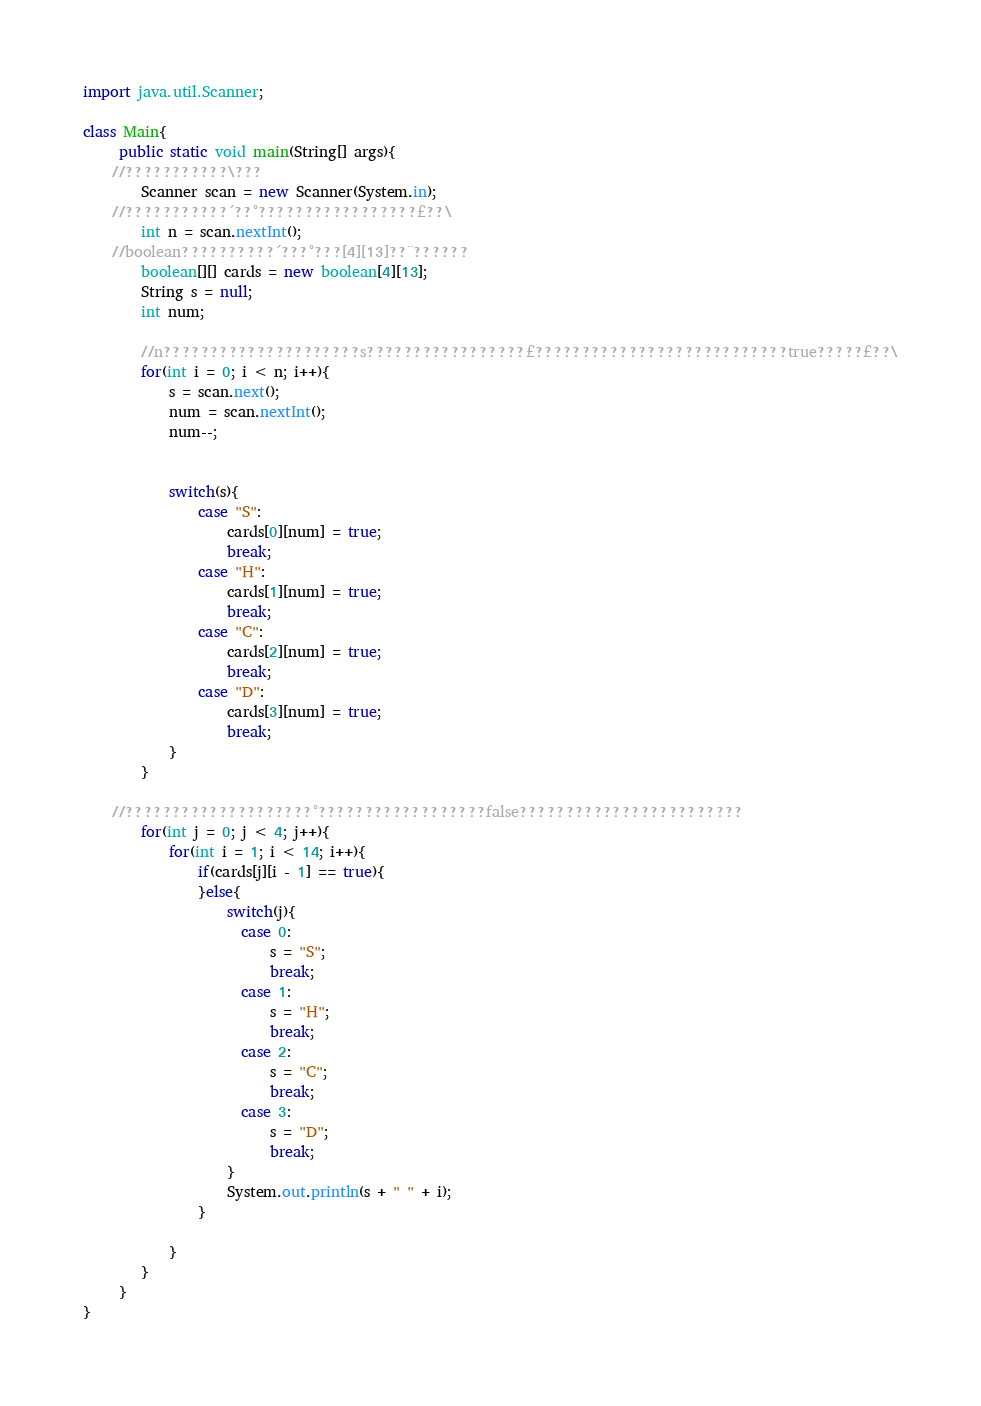Convert code to text. <code><loc_0><loc_0><loc_500><loc_500><_Java_>import java.util.Scanner;

class Main{
     public static void main(String[] args){
	//???????????\???
    	Scanner scan = new Scanner(System.in);
	//???????????´??°?????????????????£??\
    	int n = scan.nextInt();
	//boolean??????????´???°???[4][13]??¨??????
    	boolean[][] cards = new boolean[4][13];
    	String s = null;
    	int num;
    	
    	//n?????????????????????s?????????????????£???????????????????????????true?????£??\
    	for(int i = 0; i < n; i++){
    		s = scan.next();
    		num = scan.nextInt();
    		num--;
    		
    		
    		switch(s){
    			case "S":
    				cards[0][num] = true;
    				break;
    			case "H":
    				cards[1][num] = true;
    				break;
    			case "C":
    				cards[2][num] = true;
    				break;
    			case "D":
    				cards[3][num] = true;
    				break;
    		}
    	}
    	
	//????????????????????°??????????????????false????????????????????????
    	for(int j = 0; j < 4; j++){
    		for(int i = 1; i < 14; i++){
    			if(cards[j][i - 1] == true){   				
    			}else{
    				switch(j){
    				  case 0:
    					  s = "S";
    					  break;
    				  case 1:
    					  s = "H";
    					  break;
    				  case 2:
    					  s = "C";
    					  break;
    				  case 3:
    					  s = "D";
    					  break;
    				}   				
    				System.out.println(s + " " + i);
    			}
    			
    		}
    	}
     }
}</code> 